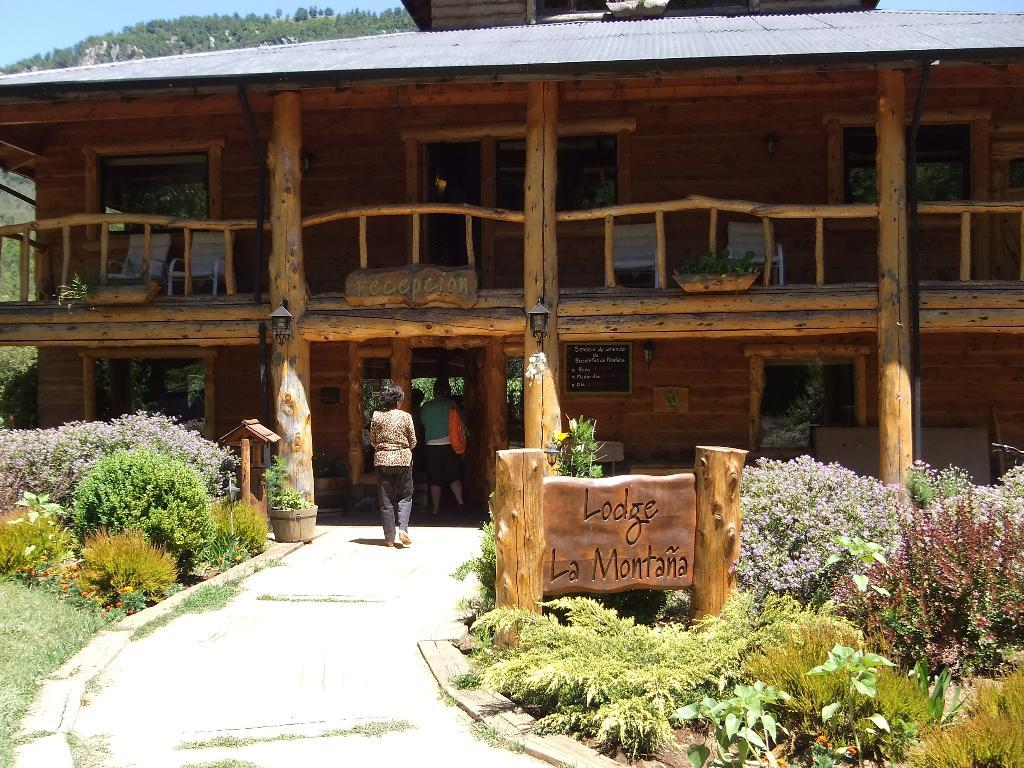<image>
Relay a brief, clear account of the picture shown. Lodge La Montana engraved into the sign in the front of this lodge. 